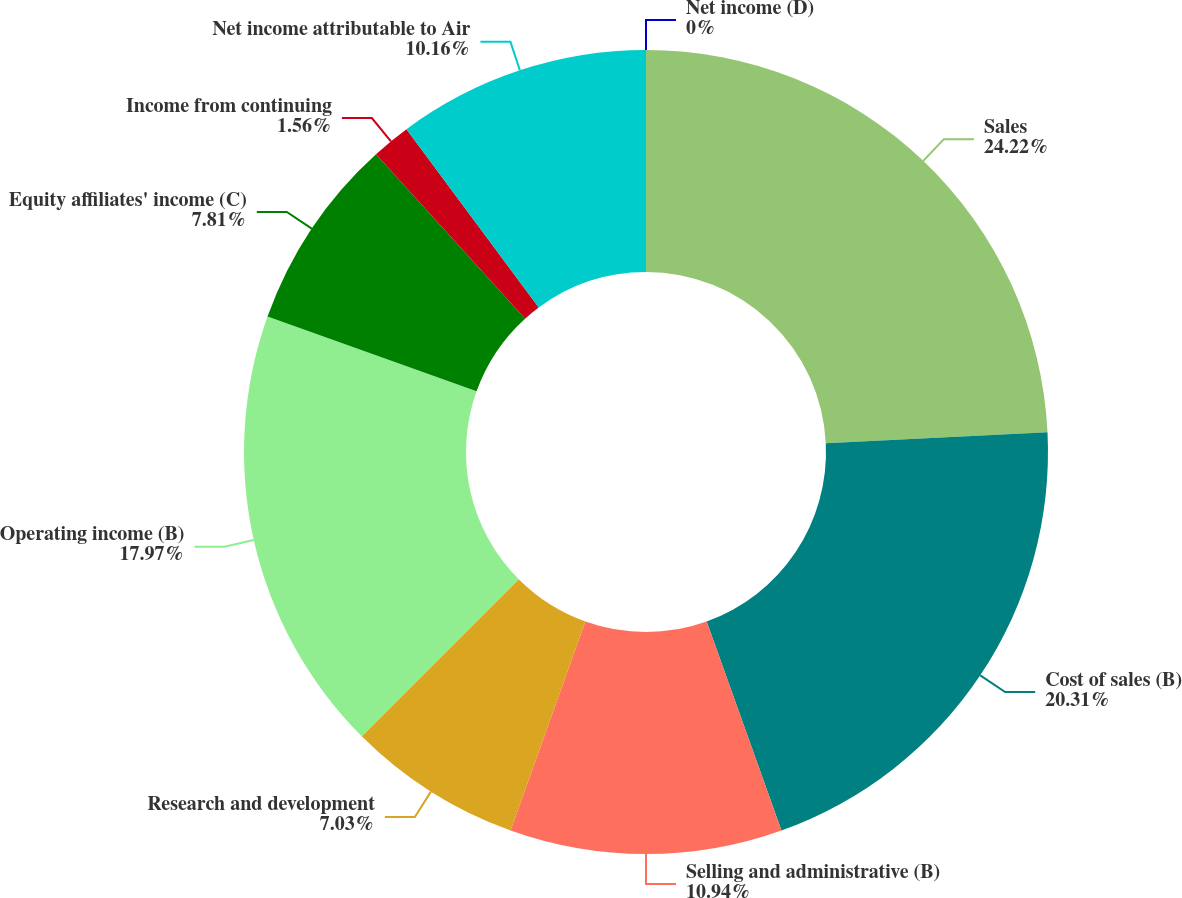Convert chart. <chart><loc_0><loc_0><loc_500><loc_500><pie_chart><fcel>Sales<fcel>Cost of sales (B)<fcel>Selling and administrative (B)<fcel>Research and development<fcel>Operating income (B)<fcel>Equity affiliates' income (C)<fcel>Income from continuing<fcel>Net income attributable to Air<fcel>Net income (D)<nl><fcel>24.22%<fcel>20.31%<fcel>10.94%<fcel>7.03%<fcel>17.97%<fcel>7.81%<fcel>1.56%<fcel>10.16%<fcel>0.0%<nl></chart> 